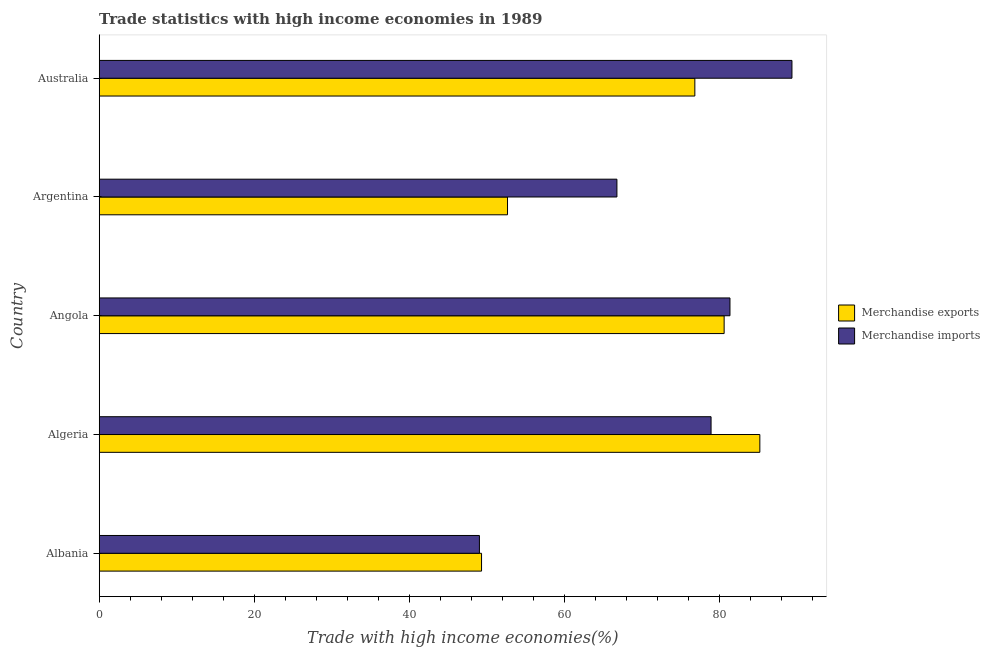How many different coloured bars are there?
Your answer should be very brief. 2. How many bars are there on the 5th tick from the bottom?
Give a very brief answer. 2. What is the label of the 4th group of bars from the top?
Your answer should be very brief. Algeria. What is the merchandise imports in Australia?
Your answer should be compact. 89.34. Across all countries, what is the maximum merchandise imports?
Your response must be concise. 89.34. Across all countries, what is the minimum merchandise exports?
Give a very brief answer. 49.31. In which country was the merchandise exports maximum?
Provide a short and direct response. Algeria. In which country was the merchandise exports minimum?
Offer a terse response. Albania. What is the total merchandise exports in the graph?
Your answer should be compact. 344.59. What is the difference between the merchandise imports in Angola and that in Argentina?
Make the answer very short. 14.58. What is the difference between the merchandise exports in Angola and the merchandise imports in Argentina?
Offer a terse response. 13.83. What is the average merchandise exports per country?
Make the answer very short. 68.92. What is the difference between the merchandise exports and merchandise imports in Albania?
Give a very brief answer. 0.27. What is the ratio of the merchandise imports in Argentina to that in Australia?
Your answer should be compact. 0.75. Is the merchandise imports in Algeria less than that in Argentina?
Make the answer very short. No. What is the difference between the highest and the second highest merchandise imports?
Provide a succinct answer. 7.99. What is the difference between the highest and the lowest merchandise exports?
Offer a very short reply. 35.89. Is the sum of the merchandise exports in Argentina and Australia greater than the maximum merchandise imports across all countries?
Offer a terse response. Yes. How many bars are there?
Offer a terse response. 10. Are all the bars in the graph horizontal?
Ensure brevity in your answer.  Yes. How many countries are there in the graph?
Provide a short and direct response. 5. What is the difference between two consecutive major ticks on the X-axis?
Provide a succinct answer. 20. Are the values on the major ticks of X-axis written in scientific E-notation?
Keep it short and to the point. No. Where does the legend appear in the graph?
Your answer should be compact. Center right. How many legend labels are there?
Your response must be concise. 2. What is the title of the graph?
Give a very brief answer. Trade statistics with high income economies in 1989. Does "RDB concessional" appear as one of the legend labels in the graph?
Your answer should be very brief. No. What is the label or title of the X-axis?
Your answer should be compact. Trade with high income economies(%). What is the label or title of the Y-axis?
Your answer should be compact. Country. What is the Trade with high income economies(%) of Merchandise exports in Albania?
Provide a short and direct response. 49.31. What is the Trade with high income economies(%) in Merchandise imports in Albania?
Your answer should be very brief. 49.04. What is the Trade with high income economies(%) in Merchandise exports in Algeria?
Ensure brevity in your answer.  85.2. What is the Trade with high income economies(%) of Merchandise imports in Algeria?
Your answer should be compact. 78.91. What is the Trade with high income economies(%) in Merchandise exports in Angola?
Your response must be concise. 80.6. What is the Trade with high income economies(%) of Merchandise imports in Angola?
Give a very brief answer. 81.35. What is the Trade with high income economies(%) of Merchandise exports in Argentina?
Ensure brevity in your answer.  52.66. What is the Trade with high income economies(%) of Merchandise imports in Argentina?
Offer a terse response. 66.77. What is the Trade with high income economies(%) in Merchandise exports in Australia?
Your response must be concise. 76.82. What is the Trade with high income economies(%) of Merchandise imports in Australia?
Your response must be concise. 89.34. Across all countries, what is the maximum Trade with high income economies(%) of Merchandise exports?
Make the answer very short. 85.2. Across all countries, what is the maximum Trade with high income economies(%) in Merchandise imports?
Your response must be concise. 89.34. Across all countries, what is the minimum Trade with high income economies(%) of Merchandise exports?
Provide a short and direct response. 49.31. Across all countries, what is the minimum Trade with high income economies(%) of Merchandise imports?
Make the answer very short. 49.04. What is the total Trade with high income economies(%) of Merchandise exports in the graph?
Offer a very short reply. 344.59. What is the total Trade with high income economies(%) in Merchandise imports in the graph?
Your response must be concise. 365.41. What is the difference between the Trade with high income economies(%) in Merchandise exports in Albania and that in Algeria?
Give a very brief answer. -35.89. What is the difference between the Trade with high income economies(%) in Merchandise imports in Albania and that in Algeria?
Give a very brief answer. -29.88. What is the difference between the Trade with high income economies(%) in Merchandise exports in Albania and that in Angola?
Your answer should be compact. -31.29. What is the difference between the Trade with high income economies(%) in Merchandise imports in Albania and that in Angola?
Your response must be concise. -32.31. What is the difference between the Trade with high income economies(%) of Merchandise exports in Albania and that in Argentina?
Your answer should be compact. -3.35. What is the difference between the Trade with high income economies(%) of Merchandise imports in Albania and that in Argentina?
Your response must be concise. -17.73. What is the difference between the Trade with high income economies(%) in Merchandise exports in Albania and that in Australia?
Your answer should be very brief. -27.51. What is the difference between the Trade with high income economies(%) in Merchandise imports in Albania and that in Australia?
Ensure brevity in your answer.  -40.31. What is the difference between the Trade with high income economies(%) of Merchandise exports in Algeria and that in Angola?
Give a very brief answer. 4.61. What is the difference between the Trade with high income economies(%) of Merchandise imports in Algeria and that in Angola?
Your response must be concise. -2.44. What is the difference between the Trade with high income economies(%) in Merchandise exports in Algeria and that in Argentina?
Give a very brief answer. 32.54. What is the difference between the Trade with high income economies(%) of Merchandise imports in Algeria and that in Argentina?
Ensure brevity in your answer.  12.14. What is the difference between the Trade with high income economies(%) of Merchandise exports in Algeria and that in Australia?
Your response must be concise. 8.38. What is the difference between the Trade with high income economies(%) in Merchandise imports in Algeria and that in Australia?
Your answer should be very brief. -10.43. What is the difference between the Trade with high income economies(%) in Merchandise exports in Angola and that in Argentina?
Ensure brevity in your answer.  27.94. What is the difference between the Trade with high income economies(%) in Merchandise imports in Angola and that in Argentina?
Keep it short and to the point. 14.58. What is the difference between the Trade with high income economies(%) of Merchandise exports in Angola and that in Australia?
Provide a succinct answer. 3.78. What is the difference between the Trade with high income economies(%) in Merchandise imports in Angola and that in Australia?
Keep it short and to the point. -7.99. What is the difference between the Trade with high income economies(%) in Merchandise exports in Argentina and that in Australia?
Your answer should be compact. -24.16. What is the difference between the Trade with high income economies(%) of Merchandise imports in Argentina and that in Australia?
Your answer should be compact. -22.57. What is the difference between the Trade with high income economies(%) of Merchandise exports in Albania and the Trade with high income economies(%) of Merchandise imports in Algeria?
Offer a terse response. -29.6. What is the difference between the Trade with high income economies(%) of Merchandise exports in Albania and the Trade with high income economies(%) of Merchandise imports in Angola?
Your answer should be compact. -32.04. What is the difference between the Trade with high income economies(%) of Merchandise exports in Albania and the Trade with high income economies(%) of Merchandise imports in Argentina?
Provide a succinct answer. -17.46. What is the difference between the Trade with high income economies(%) in Merchandise exports in Albania and the Trade with high income economies(%) in Merchandise imports in Australia?
Keep it short and to the point. -40.03. What is the difference between the Trade with high income economies(%) in Merchandise exports in Algeria and the Trade with high income economies(%) in Merchandise imports in Angola?
Your answer should be compact. 3.85. What is the difference between the Trade with high income economies(%) in Merchandise exports in Algeria and the Trade with high income economies(%) in Merchandise imports in Argentina?
Make the answer very short. 18.43. What is the difference between the Trade with high income economies(%) in Merchandise exports in Algeria and the Trade with high income economies(%) in Merchandise imports in Australia?
Make the answer very short. -4.14. What is the difference between the Trade with high income economies(%) in Merchandise exports in Angola and the Trade with high income economies(%) in Merchandise imports in Argentina?
Give a very brief answer. 13.83. What is the difference between the Trade with high income economies(%) of Merchandise exports in Angola and the Trade with high income economies(%) of Merchandise imports in Australia?
Provide a succinct answer. -8.75. What is the difference between the Trade with high income economies(%) of Merchandise exports in Argentina and the Trade with high income economies(%) of Merchandise imports in Australia?
Your answer should be very brief. -36.68. What is the average Trade with high income economies(%) of Merchandise exports per country?
Give a very brief answer. 68.92. What is the average Trade with high income economies(%) of Merchandise imports per country?
Provide a succinct answer. 73.08. What is the difference between the Trade with high income economies(%) in Merchandise exports and Trade with high income economies(%) in Merchandise imports in Albania?
Offer a terse response. 0.27. What is the difference between the Trade with high income economies(%) of Merchandise exports and Trade with high income economies(%) of Merchandise imports in Algeria?
Your response must be concise. 6.29. What is the difference between the Trade with high income economies(%) in Merchandise exports and Trade with high income economies(%) in Merchandise imports in Angola?
Give a very brief answer. -0.75. What is the difference between the Trade with high income economies(%) in Merchandise exports and Trade with high income economies(%) in Merchandise imports in Argentina?
Give a very brief answer. -14.11. What is the difference between the Trade with high income economies(%) of Merchandise exports and Trade with high income economies(%) of Merchandise imports in Australia?
Ensure brevity in your answer.  -12.52. What is the ratio of the Trade with high income economies(%) of Merchandise exports in Albania to that in Algeria?
Provide a short and direct response. 0.58. What is the ratio of the Trade with high income economies(%) in Merchandise imports in Albania to that in Algeria?
Your answer should be compact. 0.62. What is the ratio of the Trade with high income economies(%) of Merchandise exports in Albania to that in Angola?
Your answer should be very brief. 0.61. What is the ratio of the Trade with high income economies(%) in Merchandise imports in Albania to that in Angola?
Offer a very short reply. 0.6. What is the ratio of the Trade with high income economies(%) in Merchandise exports in Albania to that in Argentina?
Your answer should be compact. 0.94. What is the ratio of the Trade with high income economies(%) of Merchandise imports in Albania to that in Argentina?
Your answer should be compact. 0.73. What is the ratio of the Trade with high income economies(%) of Merchandise exports in Albania to that in Australia?
Ensure brevity in your answer.  0.64. What is the ratio of the Trade with high income economies(%) of Merchandise imports in Albania to that in Australia?
Your response must be concise. 0.55. What is the ratio of the Trade with high income economies(%) in Merchandise exports in Algeria to that in Angola?
Offer a terse response. 1.06. What is the ratio of the Trade with high income economies(%) in Merchandise exports in Algeria to that in Argentina?
Your answer should be compact. 1.62. What is the ratio of the Trade with high income economies(%) in Merchandise imports in Algeria to that in Argentina?
Your answer should be very brief. 1.18. What is the ratio of the Trade with high income economies(%) of Merchandise exports in Algeria to that in Australia?
Provide a succinct answer. 1.11. What is the ratio of the Trade with high income economies(%) of Merchandise imports in Algeria to that in Australia?
Ensure brevity in your answer.  0.88. What is the ratio of the Trade with high income economies(%) in Merchandise exports in Angola to that in Argentina?
Ensure brevity in your answer.  1.53. What is the ratio of the Trade with high income economies(%) in Merchandise imports in Angola to that in Argentina?
Offer a very short reply. 1.22. What is the ratio of the Trade with high income economies(%) of Merchandise exports in Angola to that in Australia?
Keep it short and to the point. 1.05. What is the ratio of the Trade with high income economies(%) of Merchandise imports in Angola to that in Australia?
Your answer should be very brief. 0.91. What is the ratio of the Trade with high income economies(%) in Merchandise exports in Argentina to that in Australia?
Ensure brevity in your answer.  0.69. What is the ratio of the Trade with high income economies(%) of Merchandise imports in Argentina to that in Australia?
Provide a succinct answer. 0.75. What is the difference between the highest and the second highest Trade with high income economies(%) in Merchandise exports?
Your response must be concise. 4.61. What is the difference between the highest and the second highest Trade with high income economies(%) in Merchandise imports?
Give a very brief answer. 7.99. What is the difference between the highest and the lowest Trade with high income economies(%) in Merchandise exports?
Provide a succinct answer. 35.89. What is the difference between the highest and the lowest Trade with high income economies(%) of Merchandise imports?
Give a very brief answer. 40.31. 